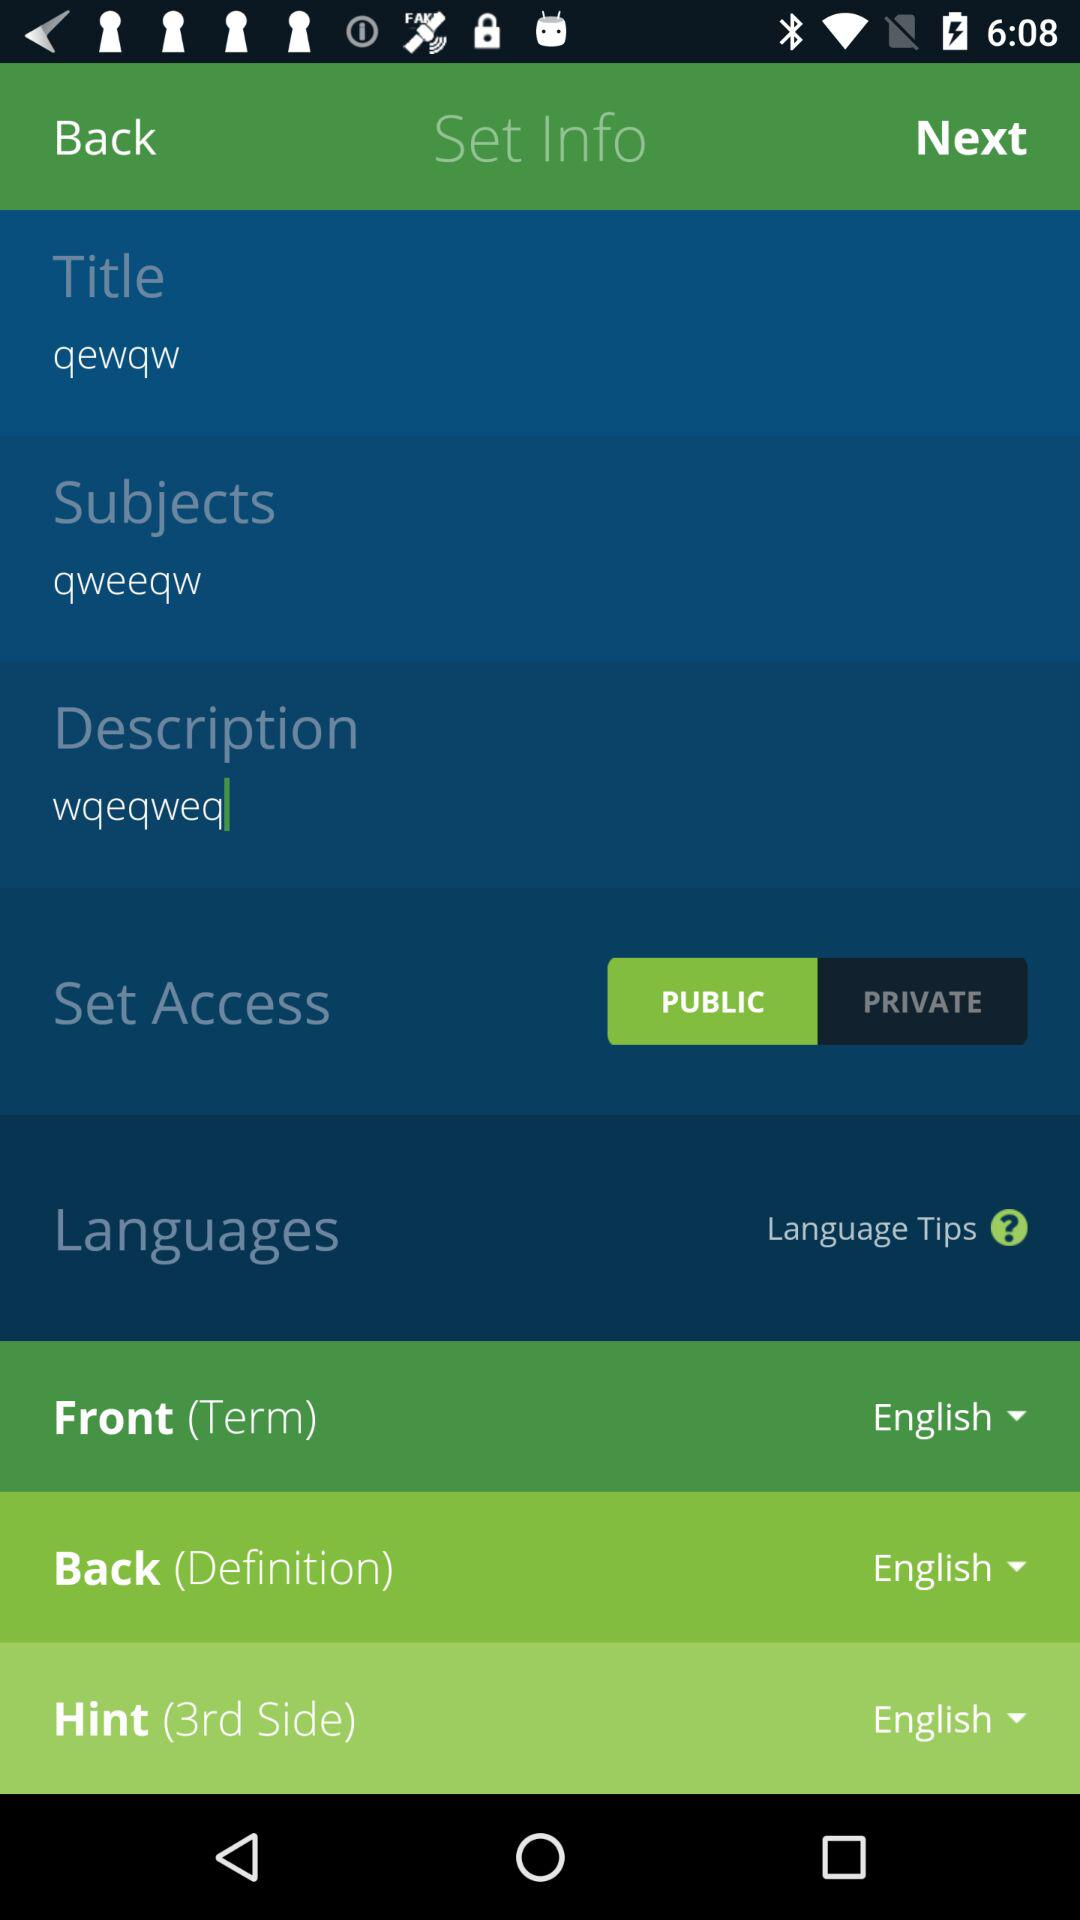What are the subjects? The subject is "qweeqw". 